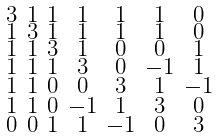<formula> <loc_0><loc_0><loc_500><loc_500>\begin{smallmatrix} 3 & 1 & 1 & 1 & 1 & 1 & 0 \\ 1 & 3 & 1 & 1 & 1 & 1 & 0 \\ 1 & 1 & 3 & 1 & 0 & 0 & 1 \\ 1 & 1 & 1 & 3 & 0 & - 1 & 1 \\ 1 & 1 & 0 & 0 & 3 & 1 & - 1 \\ 1 & 1 & 0 & - 1 & 1 & 3 & 0 \\ 0 & 0 & 1 & 1 & - 1 & 0 & 3 \end{smallmatrix}</formula> 